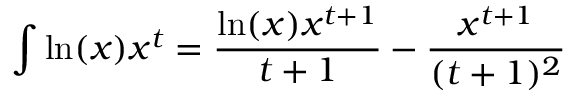<formula> <loc_0><loc_0><loc_500><loc_500>\int \ln ( x ) x ^ { t } = { \frac { \ln ( x ) x ^ { t + 1 } } { t + 1 } } - { \frac { x ^ { t + 1 } } { ( t + 1 ) ^ { 2 } } }</formula> 